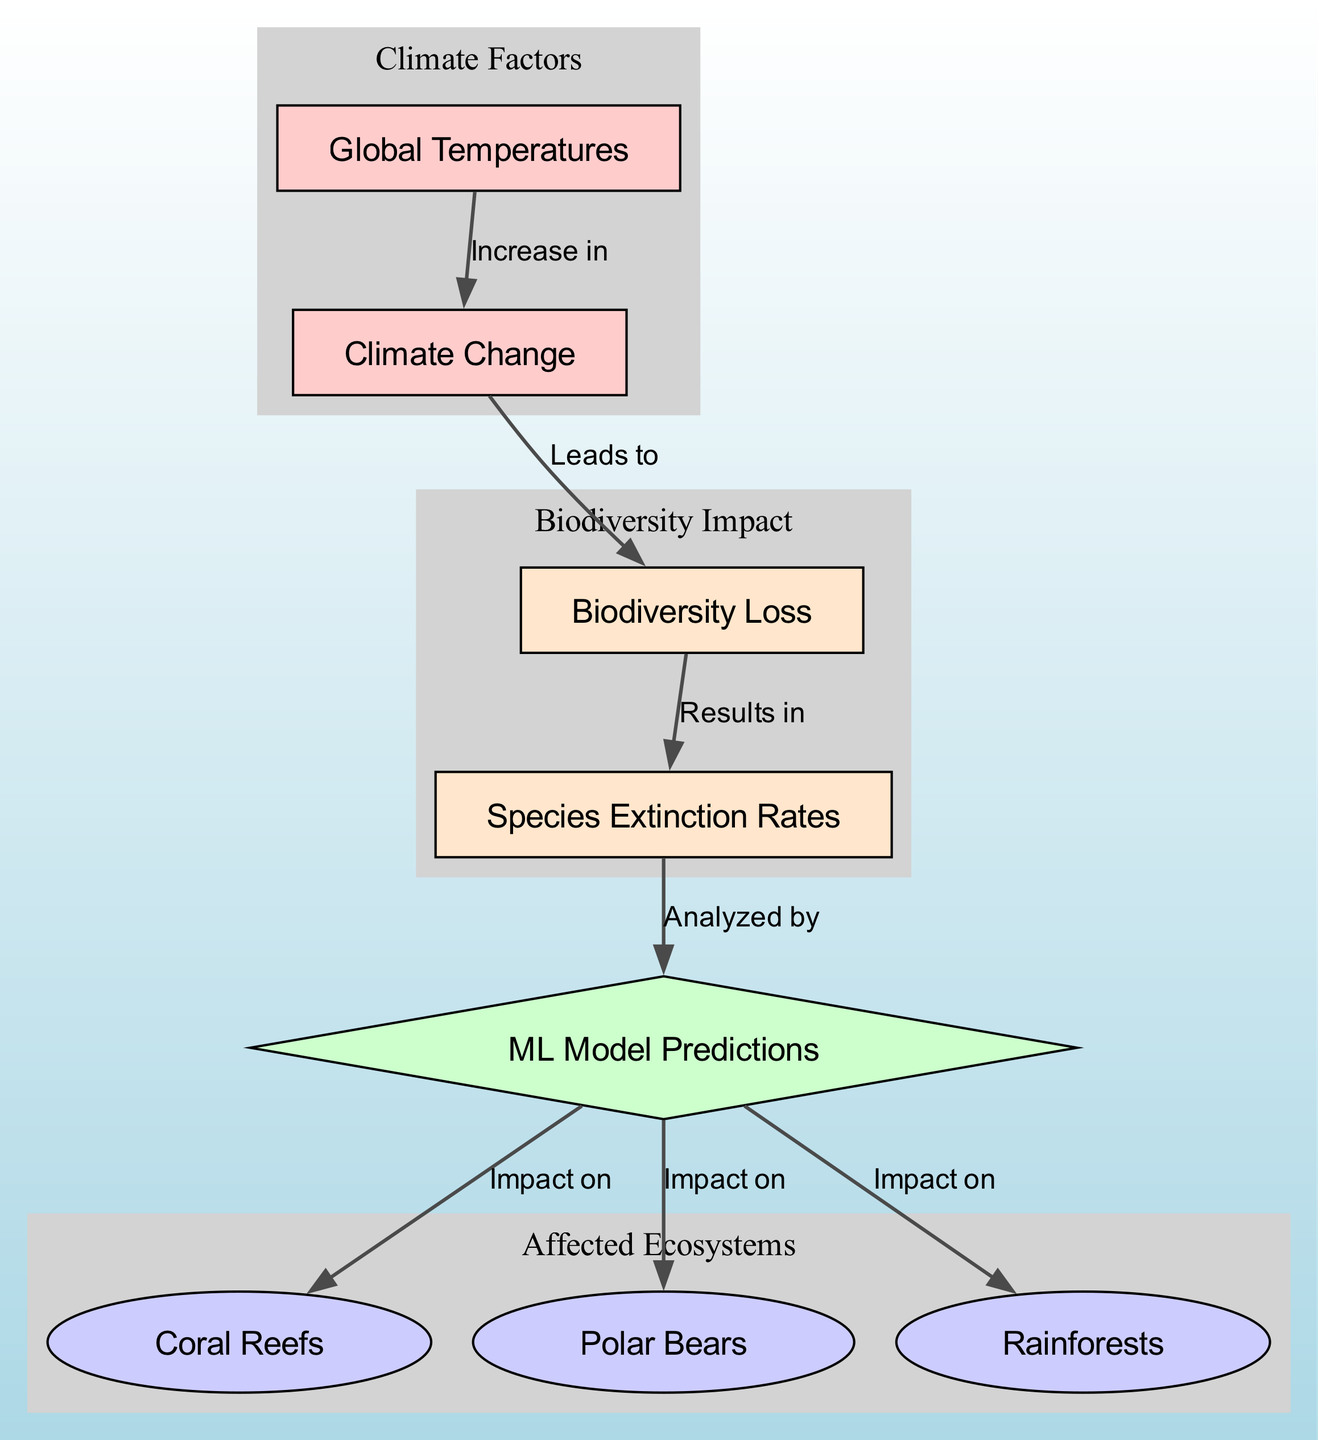What is the first node in the diagram? The first node in the diagram is "Global Temperatures," which is indicated at the top of the flow.
Answer: Global Temperatures How many edges are present in the diagram? By counting the connections between the nodes, there are a total of 6 edges depicted in the diagram.
Answer: 6 What node is affected by the "ML Model Predictions"? The nodes that are impacted by the "ML Model Predictions" are "Coral Reefs," "Polar Bears," and "Rainforests." The arrows indicate direct connections from the ML model to these ecosystems.
Answer: Coral Reefs, Polar Bears, Rainforests What does "Climate Change" lead to? "Climate Change" directly leads to "Biodiversity Loss," as indicated by the arrow showing the relationship between these two nodes.
Answer: Biodiversity Loss What results from "Biodiversity Loss"? "Biodiversity Loss" results in "Species Extinction," which is clearly shown in the diagram with a direct link labeled as such.
Answer: Species Extinction How is "Species Extinction" analyzed? "Species Extinction" is analyzed by "ML Model Predictions," as indicated by the directed edge that points from one to the other.
Answer: ML Model Predictions What is the relationship between "Global Temperatures" and "Climate Change"? The relationship between "Global Temperatures" and "Climate Change" is that an increase in global temperatures leads to climate change. This is visually represented by an edge labeled "Increase in."
Answer: Increase in Which ecosystems are predicted to be affected according to the diagram? The ecosystems predicted to be affected according to the diagram are "Coral Reefs," "Polar Bears," and "Rainforests," shown by their connections to the predictions node.
Answer: Coral Reefs, Polar Bears, Rainforests What does the diamond shape represent in the diagram? The diamond shape represents the "ML Model Predictions," which is indicative of the analytical aspect within the diagram's context.
Answer: ML Model Predictions 